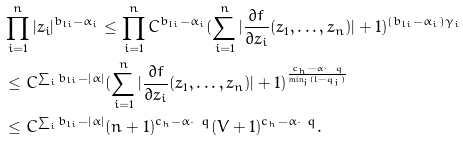<formula> <loc_0><loc_0><loc_500><loc_500>& \prod ^ { n } _ { i = 1 } | z _ { i } | ^ { b _ { l i } - \alpha _ { i } } \leq \prod ^ { n } _ { i = 1 } C ^ { b _ { l i } - \alpha _ { i } } ( \sum ^ { n } _ { i = 1 } | \frac { \partial f } { \partial z _ { i } } ( z _ { 1 } , \dots , z _ { n } ) | + 1 ) ^ { ( b _ { l i } - \alpha _ { i } ) \gamma _ { i } } \\ & \leq C ^ { \sum _ { i } b _ { l i } - | \alpha | } ( \sum ^ { n } _ { i = 1 } | \frac { \partial f } { \partial z _ { i } } ( z _ { 1 } , \dots , z _ { n } ) | + 1 ) ^ { \frac { c _ { h } - \alpha \cdot \ q } { \min _ { j } ( 1 - q _ { j } ) } } \\ & \leq C ^ { \sum _ { i } b _ { l i } - | \alpha | } ( n + 1 ) ^ { c _ { h } - \alpha \cdot \ q } ( V + 1 ) ^ { c _ { h } - \alpha \cdot \ q } .</formula> 